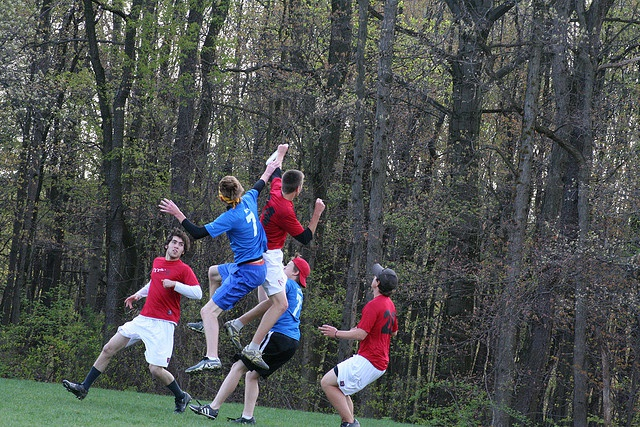Describe the objects in this image and their specific colors. I can see people in gray, blue, black, and lightblue tones, people in gray, lavender, black, and brown tones, people in gray, black, darkgray, lavender, and maroon tones, people in gray, brown, black, lavender, and darkgray tones, and people in gray, black, darkgray, and blue tones in this image. 